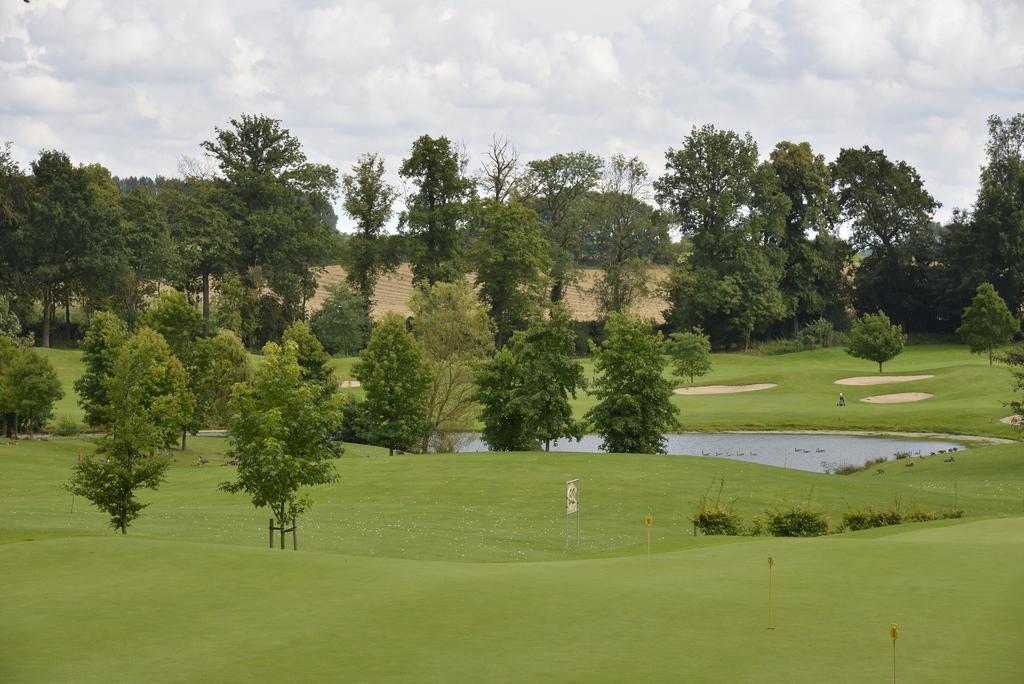How would you summarize this image in a sentence or two? In this image there is grassland, in the middle there is a pound and there are trees and the sky. 